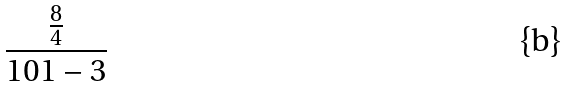<formula> <loc_0><loc_0><loc_500><loc_500>\frac { \frac { 8 } { 4 } } { 1 0 1 - 3 }</formula> 